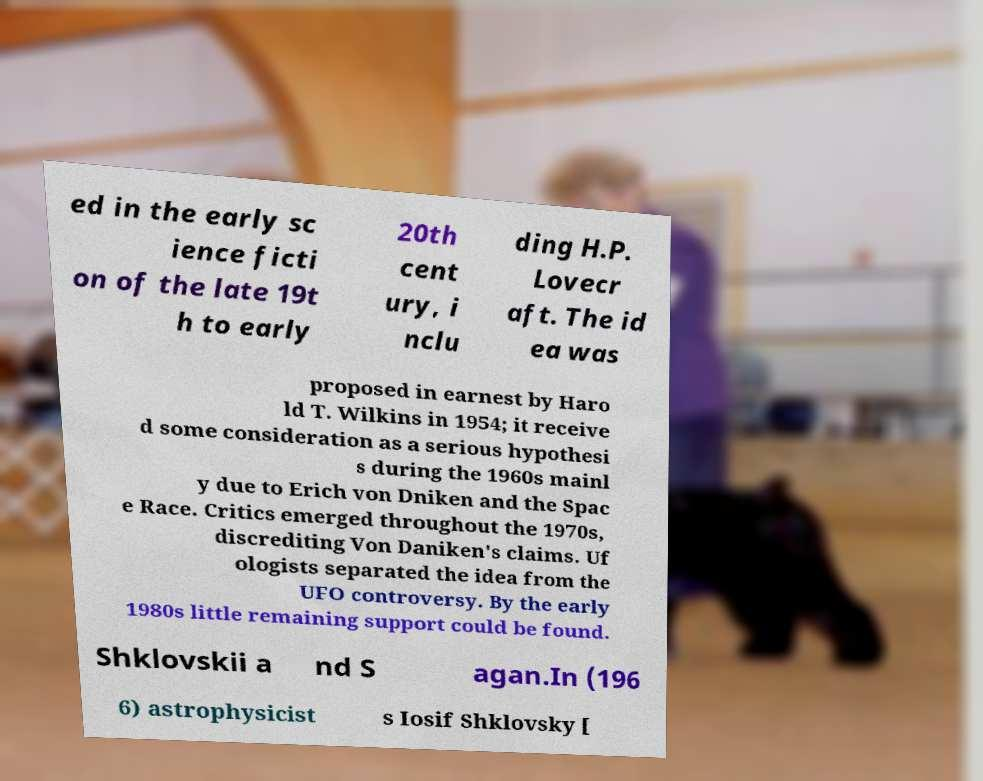What messages or text are displayed in this image? I need them in a readable, typed format. ed in the early sc ience ficti on of the late 19t h to early 20th cent ury, i nclu ding H.P. Lovecr aft. The id ea was proposed in earnest by Haro ld T. Wilkins in 1954; it receive d some consideration as a serious hypothesi s during the 1960s mainl y due to Erich von Dniken and the Spac e Race. Critics emerged throughout the 1970s, discrediting Von Daniken's claims. Uf ologists separated the idea from the UFO controversy. By the early 1980s little remaining support could be found. Shklovskii a nd S agan.In (196 6) astrophysicist s Iosif Shklovsky [ 